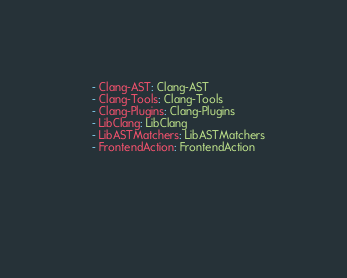Convert code to text. <code><loc_0><loc_0><loc_500><loc_500><_YAML_>    - Clang-AST: Clang-AST
    - Clang-Tools: Clang-Tools
    - Clang-Plugins: Clang-Plugins
    - LibClang: LibClang        
    - LibASTMatchers: LibASTMatchers 
    - FrontendAction: FrontendAction 

    
    
    </code> 